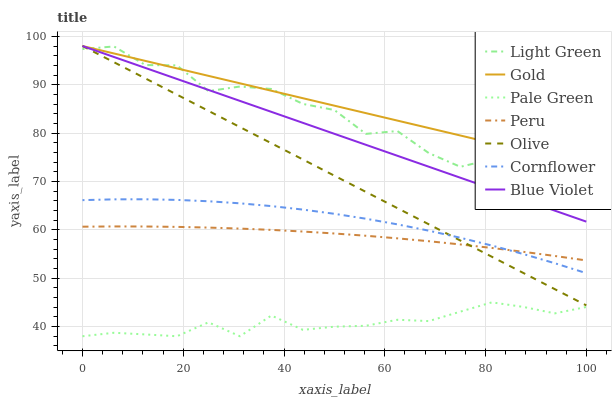Does Pale Green have the minimum area under the curve?
Answer yes or no. Yes. Does Gold have the maximum area under the curve?
Answer yes or no. Yes. Does Light Green have the minimum area under the curve?
Answer yes or no. No. Does Light Green have the maximum area under the curve?
Answer yes or no. No. Is Olive the smoothest?
Answer yes or no. Yes. Is Light Green the roughest?
Answer yes or no. Yes. Is Gold the smoothest?
Answer yes or no. No. Is Gold the roughest?
Answer yes or no. No. Does Pale Green have the lowest value?
Answer yes or no. Yes. Does Light Green have the lowest value?
Answer yes or no. No. Does Blue Violet have the highest value?
Answer yes or no. Yes. Does Light Green have the highest value?
Answer yes or no. No. Is Peru less than Gold?
Answer yes or no. Yes. Is Light Green greater than Cornflower?
Answer yes or no. Yes. Does Cornflower intersect Peru?
Answer yes or no. Yes. Is Cornflower less than Peru?
Answer yes or no. No. Is Cornflower greater than Peru?
Answer yes or no. No. Does Peru intersect Gold?
Answer yes or no. No. 